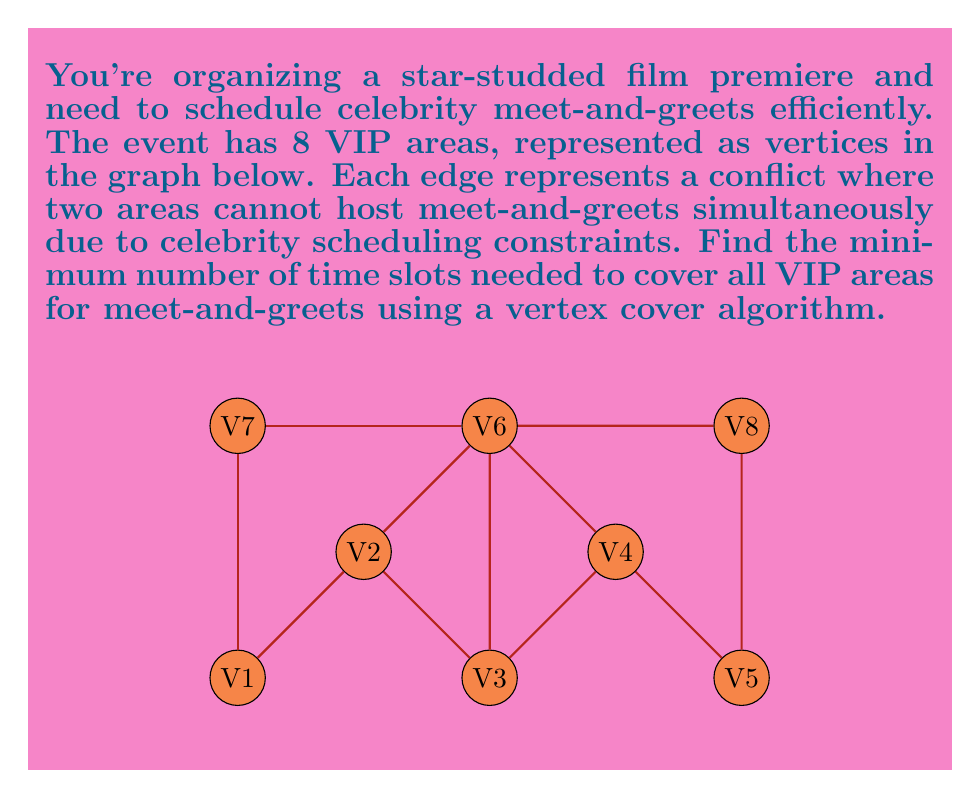Help me with this question. To solve this problem, we need to find the minimum vertex cover of the given graph. A vertex cover is a set of vertices such that every edge in the graph is incident to at least one vertex in the set. The size of this minimum vertex cover will give us the minimum number of time slots needed.

Let's solve this step-by-step:

1) First, we can use a greedy algorithm to find an approximate vertex cover:
   
   a) Select the vertex with the highest degree (most connections).
   b) Remove this vertex and all its incident edges from the graph.
   c) Repeat until no edges remain.

2) Following this algorithm:
   
   - $V6$ has the highest degree (4), so we select it and remove its edges.
   - $V2$ and $V4$ now have the highest degree (2), let's choose $V2$.
   - $V4$ still has degree 2, so we select it.
   - No edges remain.

3) This gives us a vertex cover of $\{V6, V2, V4\}$ with size 3.

4) To verify if this is indeed the minimum vertex cover, we can check if removing any vertex from this set still leaves us with a valid cover. In this case, removing any vertex would leave some edges uncovered.

5) We can also observe that this graph has a maximum matching of size 3 (e.g., $\{V1-V2, V3-V6, V4-V7\}$), and by König's theorem, in a bipartite graph, the size of a minimum vertex cover equals the size of a maximum matching.

6) While our graph is not bipartite, this property often holds for many graphs and supports our finding.

Therefore, the minimum vertex cover has size 3, meaning we need at least 3 time slots to cover all VIP areas for meet-and-greets.
Answer: 3 time slots 